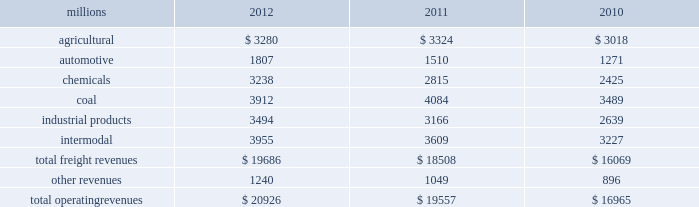Notes to the consolidated financial statements union pacific corporation and subsidiary companies for purposes of this report , unless the context otherwise requires , all references herein to the 201ccorporation 201d , 201cupc 201d , 201cwe 201d , 201cus 201d , and 201cour 201d mean union pacific corporation and its subsidiaries , including union pacific railroad company , which will be separately referred to herein as 201cuprr 201d or the 201crailroad 201d .
Nature of operations operations and segmentation 2013 we are a class i railroad operating in the u.s .
Our network includes 31868 route miles , linking pacific coast and gulf coast ports with the midwest and eastern u.s .
Gateways and providing several corridors to key mexican gateways .
We own 26020 miles and operate on the remainder pursuant to trackage rights or leases .
We serve the western two-thirds of the country and maintain coordinated schedules with other rail carriers for the handling of freight to and from the atlantic coast , the pacific coast , the southeast , the southwest , canada , and mexico .
Export and import traffic is moved through gulf coast and pacific coast ports and across the mexican and canadian borders .
The railroad , along with its subsidiaries and rail affiliates , is our one reportable operating segment .
Although we provide and review revenue by commodity group , we analyze the net financial results of the railroad as one segment due to the integrated nature of our rail network .
The table provides freight revenue by commodity group : millions 2012 2011 2010 .
Although our revenues are principally derived from customers domiciled in the u.s. , the ultimate points of origination or destination for some products transported by us are outside the u.s .
Each of our commodity groups includes revenue from shipments to and from mexico .
Included in the above table are revenues from our mexico business which amounted to $ 1.9 billion in 2012 , $ 1.8 billion in 2011 , and $ 1.6 billion in 2010 .
Basis of presentation 2013 the consolidated financial statements are presented in accordance with accounting principles generally accepted in the u.s .
( gaap ) as codified in the financial accounting standards board ( fasb ) accounting standards codification ( asc ) .
Significant accounting policies principles of consolidation 2013 the consolidated financial statements include the accounts of union pacific corporation and all of its subsidiaries .
Investments in affiliated companies ( 20% ( 20 % ) to 50% ( 50 % ) owned ) are accounted for using the equity method of accounting .
All intercompany transactions are eliminated .
We currently have no less than majority-owned investments that require consolidation under variable interest entity requirements .
Cash and cash equivalents 2013 cash equivalents consist of investments with original maturities of three months or less .
Accounts receivable 2013 accounts receivable includes receivables reduced by an allowance for doubtful accounts .
The allowance is based upon historical losses , credit worthiness of customers , and current economic conditions .
Receivables not expected to be collected in one year and the associated allowances are classified as other assets in our consolidated statements of financial position. .
Revenues from mexico are how much of total operating revenues in 2012? 
Computations: ((1.9 * 1000) / 20926)
Answer: 0.0908. 